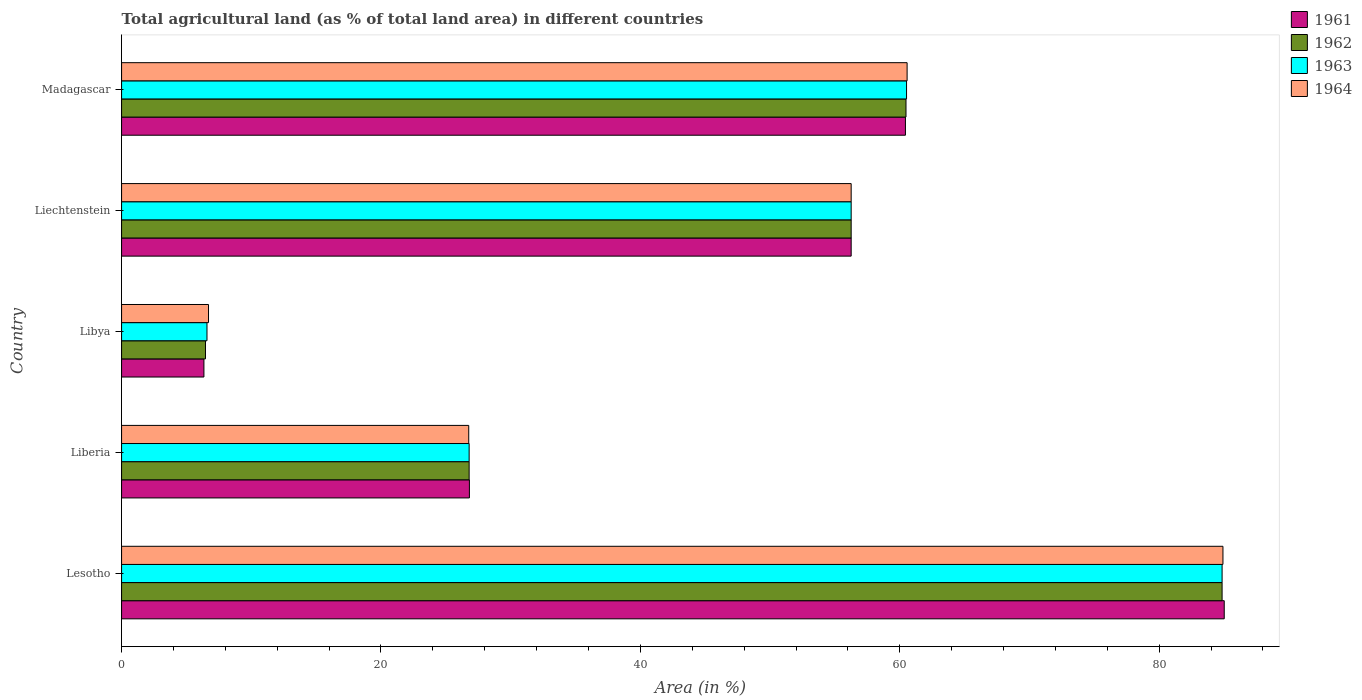Are the number of bars per tick equal to the number of legend labels?
Keep it short and to the point. Yes. How many bars are there on the 2nd tick from the top?
Your answer should be compact. 4. How many bars are there on the 3rd tick from the bottom?
Keep it short and to the point. 4. What is the label of the 4th group of bars from the top?
Make the answer very short. Liberia. What is the percentage of agricultural land in 1962 in Liberia?
Provide a short and direct response. 26.8. Across all countries, what is the maximum percentage of agricultural land in 1962?
Your answer should be very brief. 84.85. Across all countries, what is the minimum percentage of agricultural land in 1961?
Your answer should be compact. 6.35. In which country was the percentage of agricultural land in 1962 maximum?
Give a very brief answer. Lesotho. In which country was the percentage of agricultural land in 1961 minimum?
Ensure brevity in your answer.  Libya. What is the total percentage of agricultural land in 1964 in the graph?
Offer a terse response. 235.19. What is the difference between the percentage of agricultural land in 1962 in Lesotho and that in Madagascar?
Keep it short and to the point. 24.37. What is the difference between the percentage of agricultural land in 1962 in Liberia and the percentage of agricultural land in 1964 in Lesotho?
Offer a terse response. -58.12. What is the average percentage of agricultural land in 1963 per country?
Provide a succinct answer. 47. What is the difference between the percentage of agricultural land in 1963 and percentage of agricultural land in 1964 in Liberia?
Your answer should be compact. 0.03. What is the ratio of the percentage of agricultural land in 1962 in Liberia to that in Liechtenstein?
Give a very brief answer. 0.48. Is the difference between the percentage of agricultural land in 1963 in Libya and Liechtenstein greater than the difference between the percentage of agricultural land in 1964 in Libya and Liechtenstein?
Your response must be concise. No. What is the difference between the highest and the second highest percentage of agricultural land in 1962?
Your answer should be very brief. 24.37. What is the difference between the highest and the lowest percentage of agricultural land in 1962?
Your answer should be very brief. 78.38. In how many countries, is the percentage of agricultural land in 1963 greater than the average percentage of agricultural land in 1963 taken over all countries?
Provide a succinct answer. 3. Is it the case that in every country, the sum of the percentage of agricultural land in 1962 and percentage of agricultural land in 1964 is greater than the sum of percentage of agricultural land in 1961 and percentage of agricultural land in 1963?
Provide a succinct answer. No. What does the 3rd bar from the top in Liberia represents?
Offer a terse response. 1962. What does the 3rd bar from the bottom in Libya represents?
Give a very brief answer. 1963. How many bars are there?
Keep it short and to the point. 20. Are all the bars in the graph horizontal?
Your answer should be compact. Yes. How many countries are there in the graph?
Your response must be concise. 5. What is the difference between two consecutive major ticks on the X-axis?
Make the answer very short. 20. Are the values on the major ticks of X-axis written in scientific E-notation?
Offer a terse response. No. Does the graph contain any zero values?
Offer a terse response. No. How are the legend labels stacked?
Your answer should be compact. Vertical. What is the title of the graph?
Keep it short and to the point. Total agricultural land (as % of total land area) in different countries. Does "2004" appear as one of the legend labels in the graph?
Provide a short and direct response. No. What is the label or title of the X-axis?
Make the answer very short. Area (in %). What is the Area (in %) in 1961 in Lesotho?
Your answer should be very brief. 85.01. What is the Area (in %) of 1962 in Lesotho?
Your answer should be very brief. 84.85. What is the Area (in %) in 1963 in Lesotho?
Provide a succinct answer. 84.85. What is the Area (in %) in 1964 in Lesotho?
Keep it short and to the point. 84.91. What is the Area (in %) in 1961 in Liberia?
Your answer should be compact. 26.82. What is the Area (in %) in 1962 in Liberia?
Your answer should be very brief. 26.8. What is the Area (in %) in 1963 in Liberia?
Keep it short and to the point. 26.8. What is the Area (in %) of 1964 in Liberia?
Make the answer very short. 26.76. What is the Area (in %) of 1961 in Libya?
Give a very brief answer. 6.35. What is the Area (in %) in 1962 in Libya?
Your answer should be compact. 6.47. What is the Area (in %) of 1963 in Libya?
Give a very brief answer. 6.58. What is the Area (in %) in 1964 in Libya?
Your response must be concise. 6.7. What is the Area (in %) of 1961 in Liechtenstein?
Provide a short and direct response. 56.25. What is the Area (in %) in 1962 in Liechtenstein?
Provide a succinct answer. 56.25. What is the Area (in %) of 1963 in Liechtenstein?
Your response must be concise. 56.25. What is the Area (in %) in 1964 in Liechtenstein?
Offer a terse response. 56.25. What is the Area (in %) in 1961 in Madagascar?
Provide a succinct answer. 60.43. What is the Area (in %) of 1962 in Madagascar?
Provide a short and direct response. 60.48. What is the Area (in %) in 1963 in Madagascar?
Keep it short and to the point. 60.52. What is the Area (in %) in 1964 in Madagascar?
Keep it short and to the point. 60.56. Across all countries, what is the maximum Area (in %) of 1961?
Make the answer very short. 85.01. Across all countries, what is the maximum Area (in %) in 1962?
Your response must be concise. 84.85. Across all countries, what is the maximum Area (in %) in 1963?
Provide a short and direct response. 84.85. Across all countries, what is the maximum Area (in %) in 1964?
Keep it short and to the point. 84.91. Across all countries, what is the minimum Area (in %) in 1961?
Offer a very short reply. 6.35. Across all countries, what is the minimum Area (in %) of 1962?
Make the answer very short. 6.47. Across all countries, what is the minimum Area (in %) in 1963?
Offer a terse response. 6.58. Across all countries, what is the minimum Area (in %) in 1964?
Offer a very short reply. 6.7. What is the total Area (in %) of 1961 in the graph?
Offer a very short reply. 234.86. What is the total Area (in %) in 1962 in the graph?
Offer a terse response. 234.84. What is the total Area (in %) in 1963 in the graph?
Provide a succinct answer. 235. What is the total Area (in %) of 1964 in the graph?
Keep it short and to the point. 235.19. What is the difference between the Area (in %) of 1961 in Lesotho and that in Liberia?
Make the answer very short. 58.2. What is the difference between the Area (in %) in 1962 in Lesotho and that in Liberia?
Offer a terse response. 58.05. What is the difference between the Area (in %) of 1963 in Lesotho and that in Liberia?
Your answer should be very brief. 58.05. What is the difference between the Area (in %) in 1964 in Lesotho and that in Liberia?
Keep it short and to the point. 58.15. What is the difference between the Area (in %) in 1961 in Lesotho and that in Libya?
Offer a very short reply. 78.66. What is the difference between the Area (in %) in 1962 in Lesotho and that in Libya?
Offer a very short reply. 78.38. What is the difference between the Area (in %) in 1963 in Lesotho and that in Libya?
Offer a terse response. 78.26. What is the difference between the Area (in %) in 1964 in Lesotho and that in Libya?
Ensure brevity in your answer.  78.21. What is the difference between the Area (in %) in 1961 in Lesotho and that in Liechtenstein?
Your answer should be very brief. 28.76. What is the difference between the Area (in %) in 1962 in Lesotho and that in Liechtenstein?
Give a very brief answer. 28.6. What is the difference between the Area (in %) in 1963 in Lesotho and that in Liechtenstein?
Give a very brief answer. 28.6. What is the difference between the Area (in %) in 1964 in Lesotho and that in Liechtenstein?
Your answer should be compact. 28.66. What is the difference between the Area (in %) of 1961 in Lesotho and that in Madagascar?
Offer a terse response. 24.58. What is the difference between the Area (in %) of 1962 in Lesotho and that in Madagascar?
Make the answer very short. 24.37. What is the difference between the Area (in %) of 1963 in Lesotho and that in Madagascar?
Give a very brief answer. 24.33. What is the difference between the Area (in %) of 1964 in Lesotho and that in Madagascar?
Offer a terse response. 24.35. What is the difference between the Area (in %) of 1961 in Liberia and that in Libya?
Provide a short and direct response. 20.47. What is the difference between the Area (in %) of 1962 in Liberia and that in Libya?
Make the answer very short. 20.33. What is the difference between the Area (in %) in 1963 in Liberia and that in Libya?
Your answer should be very brief. 20.21. What is the difference between the Area (in %) of 1964 in Liberia and that in Libya?
Your response must be concise. 20.06. What is the difference between the Area (in %) in 1961 in Liberia and that in Liechtenstein?
Your answer should be compact. -29.43. What is the difference between the Area (in %) in 1962 in Liberia and that in Liechtenstein?
Your response must be concise. -29.45. What is the difference between the Area (in %) of 1963 in Liberia and that in Liechtenstein?
Make the answer very short. -29.45. What is the difference between the Area (in %) in 1964 in Liberia and that in Liechtenstein?
Offer a terse response. -29.48. What is the difference between the Area (in %) of 1961 in Liberia and that in Madagascar?
Make the answer very short. -33.62. What is the difference between the Area (in %) of 1962 in Liberia and that in Madagascar?
Make the answer very short. -33.68. What is the difference between the Area (in %) of 1963 in Liberia and that in Madagascar?
Offer a terse response. -33.72. What is the difference between the Area (in %) of 1964 in Liberia and that in Madagascar?
Your response must be concise. -33.8. What is the difference between the Area (in %) of 1961 in Libya and that in Liechtenstein?
Offer a very short reply. -49.9. What is the difference between the Area (in %) in 1962 in Libya and that in Liechtenstein?
Ensure brevity in your answer.  -49.78. What is the difference between the Area (in %) of 1963 in Libya and that in Liechtenstein?
Your response must be concise. -49.67. What is the difference between the Area (in %) in 1964 in Libya and that in Liechtenstein?
Make the answer very short. -49.55. What is the difference between the Area (in %) in 1961 in Libya and that in Madagascar?
Your response must be concise. -54.09. What is the difference between the Area (in %) in 1962 in Libya and that in Madagascar?
Your response must be concise. -54.01. What is the difference between the Area (in %) in 1963 in Libya and that in Madagascar?
Provide a short and direct response. -53.94. What is the difference between the Area (in %) of 1964 in Libya and that in Madagascar?
Your answer should be very brief. -53.86. What is the difference between the Area (in %) in 1961 in Liechtenstein and that in Madagascar?
Provide a short and direct response. -4.18. What is the difference between the Area (in %) of 1962 in Liechtenstein and that in Madagascar?
Offer a very short reply. -4.23. What is the difference between the Area (in %) in 1963 in Liechtenstein and that in Madagascar?
Provide a succinct answer. -4.27. What is the difference between the Area (in %) in 1964 in Liechtenstein and that in Madagascar?
Give a very brief answer. -4.31. What is the difference between the Area (in %) of 1961 in Lesotho and the Area (in %) of 1962 in Liberia?
Your response must be concise. 58.22. What is the difference between the Area (in %) of 1961 in Lesotho and the Area (in %) of 1963 in Liberia?
Your answer should be very brief. 58.22. What is the difference between the Area (in %) of 1961 in Lesotho and the Area (in %) of 1964 in Liberia?
Offer a very short reply. 58.25. What is the difference between the Area (in %) of 1962 in Lesotho and the Area (in %) of 1963 in Liberia?
Keep it short and to the point. 58.05. What is the difference between the Area (in %) of 1962 in Lesotho and the Area (in %) of 1964 in Liberia?
Your response must be concise. 58.08. What is the difference between the Area (in %) in 1963 in Lesotho and the Area (in %) in 1964 in Liberia?
Your answer should be very brief. 58.08. What is the difference between the Area (in %) in 1961 in Lesotho and the Area (in %) in 1962 in Libya?
Ensure brevity in your answer.  78.54. What is the difference between the Area (in %) in 1961 in Lesotho and the Area (in %) in 1963 in Libya?
Ensure brevity in your answer.  78.43. What is the difference between the Area (in %) of 1961 in Lesotho and the Area (in %) of 1964 in Libya?
Provide a succinct answer. 78.31. What is the difference between the Area (in %) in 1962 in Lesotho and the Area (in %) in 1963 in Libya?
Give a very brief answer. 78.26. What is the difference between the Area (in %) in 1962 in Lesotho and the Area (in %) in 1964 in Libya?
Give a very brief answer. 78.15. What is the difference between the Area (in %) in 1963 in Lesotho and the Area (in %) in 1964 in Libya?
Give a very brief answer. 78.15. What is the difference between the Area (in %) of 1961 in Lesotho and the Area (in %) of 1962 in Liechtenstein?
Offer a terse response. 28.76. What is the difference between the Area (in %) in 1961 in Lesotho and the Area (in %) in 1963 in Liechtenstein?
Your answer should be compact. 28.76. What is the difference between the Area (in %) of 1961 in Lesotho and the Area (in %) of 1964 in Liechtenstein?
Ensure brevity in your answer.  28.76. What is the difference between the Area (in %) of 1962 in Lesotho and the Area (in %) of 1963 in Liechtenstein?
Provide a short and direct response. 28.6. What is the difference between the Area (in %) of 1962 in Lesotho and the Area (in %) of 1964 in Liechtenstein?
Keep it short and to the point. 28.6. What is the difference between the Area (in %) of 1963 in Lesotho and the Area (in %) of 1964 in Liechtenstein?
Your answer should be compact. 28.6. What is the difference between the Area (in %) in 1961 in Lesotho and the Area (in %) in 1962 in Madagascar?
Offer a very short reply. 24.54. What is the difference between the Area (in %) in 1961 in Lesotho and the Area (in %) in 1963 in Madagascar?
Your answer should be compact. 24.49. What is the difference between the Area (in %) of 1961 in Lesotho and the Area (in %) of 1964 in Madagascar?
Give a very brief answer. 24.45. What is the difference between the Area (in %) in 1962 in Lesotho and the Area (in %) in 1963 in Madagascar?
Make the answer very short. 24.33. What is the difference between the Area (in %) of 1962 in Lesotho and the Area (in %) of 1964 in Madagascar?
Provide a short and direct response. 24.29. What is the difference between the Area (in %) in 1963 in Lesotho and the Area (in %) in 1964 in Madagascar?
Make the answer very short. 24.29. What is the difference between the Area (in %) in 1961 in Liberia and the Area (in %) in 1962 in Libya?
Provide a short and direct response. 20.35. What is the difference between the Area (in %) in 1961 in Liberia and the Area (in %) in 1963 in Libya?
Your answer should be compact. 20.23. What is the difference between the Area (in %) of 1961 in Liberia and the Area (in %) of 1964 in Libya?
Your response must be concise. 20.11. What is the difference between the Area (in %) of 1962 in Liberia and the Area (in %) of 1963 in Libya?
Provide a short and direct response. 20.21. What is the difference between the Area (in %) of 1962 in Liberia and the Area (in %) of 1964 in Libya?
Your answer should be compact. 20.09. What is the difference between the Area (in %) in 1963 in Liberia and the Area (in %) in 1964 in Libya?
Provide a succinct answer. 20.09. What is the difference between the Area (in %) of 1961 in Liberia and the Area (in %) of 1962 in Liechtenstein?
Provide a short and direct response. -29.43. What is the difference between the Area (in %) of 1961 in Liberia and the Area (in %) of 1963 in Liechtenstein?
Give a very brief answer. -29.43. What is the difference between the Area (in %) of 1961 in Liberia and the Area (in %) of 1964 in Liechtenstein?
Ensure brevity in your answer.  -29.43. What is the difference between the Area (in %) in 1962 in Liberia and the Area (in %) in 1963 in Liechtenstein?
Offer a terse response. -29.45. What is the difference between the Area (in %) in 1962 in Liberia and the Area (in %) in 1964 in Liechtenstein?
Your answer should be compact. -29.45. What is the difference between the Area (in %) in 1963 in Liberia and the Area (in %) in 1964 in Liechtenstein?
Offer a very short reply. -29.45. What is the difference between the Area (in %) of 1961 in Liberia and the Area (in %) of 1962 in Madagascar?
Offer a terse response. -33.66. What is the difference between the Area (in %) in 1961 in Liberia and the Area (in %) in 1963 in Madagascar?
Your response must be concise. -33.7. What is the difference between the Area (in %) of 1961 in Liberia and the Area (in %) of 1964 in Madagascar?
Keep it short and to the point. -33.75. What is the difference between the Area (in %) in 1962 in Liberia and the Area (in %) in 1963 in Madagascar?
Keep it short and to the point. -33.72. What is the difference between the Area (in %) of 1962 in Liberia and the Area (in %) of 1964 in Madagascar?
Give a very brief answer. -33.77. What is the difference between the Area (in %) in 1963 in Liberia and the Area (in %) in 1964 in Madagascar?
Your answer should be compact. -33.77. What is the difference between the Area (in %) in 1961 in Libya and the Area (in %) in 1962 in Liechtenstein?
Provide a short and direct response. -49.9. What is the difference between the Area (in %) of 1961 in Libya and the Area (in %) of 1963 in Liechtenstein?
Make the answer very short. -49.9. What is the difference between the Area (in %) of 1961 in Libya and the Area (in %) of 1964 in Liechtenstein?
Offer a terse response. -49.9. What is the difference between the Area (in %) in 1962 in Libya and the Area (in %) in 1963 in Liechtenstein?
Keep it short and to the point. -49.78. What is the difference between the Area (in %) in 1962 in Libya and the Area (in %) in 1964 in Liechtenstein?
Ensure brevity in your answer.  -49.78. What is the difference between the Area (in %) in 1963 in Libya and the Area (in %) in 1964 in Liechtenstein?
Your response must be concise. -49.67. What is the difference between the Area (in %) in 1961 in Libya and the Area (in %) in 1962 in Madagascar?
Keep it short and to the point. -54.13. What is the difference between the Area (in %) of 1961 in Libya and the Area (in %) of 1963 in Madagascar?
Your response must be concise. -54.17. What is the difference between the Area (in %) of 1961 in Libya and the Area (in %) of 1964 in Madagascar?
Make the answer very short. -54.22. What is the difference between the Area (in %) of 1962 in Libya and the Area (in %) of 1963 in Madagascar?
Provide a short and direct response. -54.05. What is the difference between the Area (in %) of 1962 in Libya and the Area (in %) of 1964 in Madagascar?
Keep it short and to the point. -54.09. What is the difference between the Area (in %) of 1963 in Libya and the Area (in %) of 1964 in Madagascar?
Your answer should be very brief. -53.98. What is the difference between the Area (in %) in 1961 in Liechtenstein and the Area (in %) in 1962 in Madagascar?
Provide a succinct answer. -4.23. What is the difference between the Area (in %) of 1961 in Liechtenstein and the Area (in %) of 1963 in Madagascar?
Offer a very short reply. -4.27. What is the difference between the Area (in %) in 1961 in Liechtenstein and the Area (in %) in 1964 in Madagascar?
Offer a terse response. -4.31. What is the difference between the Area (in %) in 1962 in Liechtenstein and the Area (in %) in 1963 in Madagascar?
Your answer should be compact. -4.27. What is the difference between the Area (in %) of 1962 in Liechtenstein and the Area (in %) of 1964 in Madagascar?
Give a very brief answer. -4.31. What is the difference between the Area (in %) in 1963 in Liechtenstein and the Area (in %) in 1964 in Madagascar?
Your answer should be compact. -4.31. What is the average Area (in %) of 1961 per country?
Make the answer very short. 46.97. What is the average Area (in %) in 1962 per country?
Provide a succinct answer. 46.97. What is the average Area (in %) of 1963 per country?
Provide a succinct answer. 47. What is the average Area (in %) in 1964 per country?
Provide a short and direct response. 47.04. What is the difference between the Area (in %) in 1961 and Area (in %) in 1962 in Lesotho?
Offer a very short reply. 0.16. What is the difference between the Area (in %) of 1961 and Area (in %) of 1963 in Lesotho?
Make the answer very short. 0.16. What is the difference between the Area (in %) of 1961 and Area (in %) of 1964 in Lesotho?
Keep it short and to the point. 0.1. What is the difference between the Area (in %) in 1962 and Area (in %) in 1964 in Lesotho?
Make the answer very short. -0.07. What is the difference between the Area (in %) of 1963 and Area (in %) of 1964 in Lesotho?
Give a very brief answer. -0.07. What is the difference between the Area (in %) in 1961 and Area (in %) in 1962 in Liberia?
Give a very brief answer. 0.02. What is the difference between the Area (in %) of 1961 and Area (in %) of 1963 in Liberia?
Provide a short and direct response. 0.02. What is the difference between the Area (in %) of 1961 and Area (in %) of 1964 in Liberia?
Give a very brief answer. 0.05. What is the difference between the Area (in %) of 1962 and Area (in %) of 1964 in Liberia?
Your answer should be compact. 0.03. What is the difference between the Area (in %) of 1963 and Area (in %) of 1964 in Liberia?
Your answer should be very brief. 0.03. What is the difference between the Area (in %) of 1961 and Area (in %) of 1962 in Libya?
Your response must be concise. -0.12. What is the difference between the Area (in %) of 1961 and Area (in %) of 1963 in Libya?
Make the answer very short. -0.24. What is the difference between the Area (in %) of 1961 and Area (in %) of 1964 in Libya?
Make the answer very short. -0.35. What is the difference between the Area (in %) of 1962 and Area (in %) of 1963 in Libya?
Your response must be concise. -0.11. What is the difference between the Area (in %) of 1962 and Area (in %) of 1964 in Libya?
Offer a terse response. -0.23. What is the difference between the Area (in %) of 1963 and Area (in %) of 1964 in Libya?
Keep it short and to the point. -0.12. What is the difference between the Area (in %) in 1961 and Area (in %) in 1963 in Liechtenstein?
Offer a terse response. 0. What is the difference between the Area (in %) in 1961 and Area (in %) in 1964 in Liechtenstein?
Offer a very short reply. 0. What is the difference between the Area (in %) in 1962 and Area (in %) in 1963 in Liechtenstein?
Give a very brief answer. 0. What is the difference between the Area (in %) in 1962 and Area (in %) in 1964 in Liechtenstein?
Offer a terse response. 0. What is the difference between the Area (in %) in 1961 and Area (in %) in 1962 in Madagascar?
Offer a very short reply. -0.04. What is the difference between the Area (in %) of 1961 and Area (in %) of 1963 in Madagascar?
Make the answer very short. -0.09. What is the difference between the Area (in %) in 1961 and Area (in %) in 1964 in Madagascar?
Provide a succinct answer. -0.13. What is the difference between the Area (in %) of 1962 and Area (in %) of 1963 in Madagascar?
Ensure brevity in your answer.  -0.04. What is the difference between the Area (in %) of 1962 and Area (in %) of 1964 in Madagascar?
Keep it short and to the point. -0.09. What is the difference between the Area (in %) of 1963 and Area (in %) of 1964 in Madagascar?
Make the answer very short. -0.04. What is the ratio of the Area (in %) in 1961 in Lesotho to that in Liberia?
Make the answer very short. 3.17. What is the ratio of the Area (in %) in 1962 in Lesotho to that in Liberia?
Your answer should be compact. 3.17. What is the ratio of the Area (in %) in 1963 in Lesotho to that in Liberia?
Offer a very short reply. 3.17. What is the ratio of the Area (in %) in 1964 in Lesotho to that in Liberia?
Make the answer very short. 3.17. What is the ratio of the Area (in %) in 1961 in Lesotho to that in Libya?
Your answer should be compact. 13.39. What is the ratio of the Area (in %) of 1962 in Lesotho to that in Libya?
Keep it short and to the point. 13.12. What is the ratio of the Area (in %) of 1963 in Lesotho to that in Libya?
Make the answer very short. 12.89. What is the ratio of the Area (in %) of 1964 in Lesotho to that in Libya?
Keep it short and to the point. 12.67. What is the ratio of the Area (in %) in 1961 in Lesotho to that in Liechtenstein?
Give a very brief answer. 1.51. What is the ratio of the Area (in %) of 1962 in Lesotho to that in Liechtenstein?
Your answer should be compact. 1.51. What is the ratio of the Area (in %) of 1963 in Lesotho to that in Liechtenstein?
Give a very brief answer. 1.51. What is the ratio of the Area (in %) of 1964 in Lesotho to that in Liechtenstein?
Your answer should be very brief. 1.51. What is the ratio of the Area (in %) of 1961 in Lesotho to that in Madagascar?
Your answer should be compact. 1.41. What is the ratio of the Area (in %) in 1962 in Lesotho to that in Madagascar?
Keep it short and to the point. 1.4. What is the ratio of the Area (in %) in 1963 in Lesotho to that in Madagascar?
Ensure brevity in your answer.  1.4. What is the ratio of the Area (in %) in 1964 in Lesotho to that in Madagascar?
Make the answer very short. 1.4. What is the ratio of the Area (in %) of 1961 in Liberia to that in Libya?
Offer a very short reply. 4.22. What is the ratio of the Area (in %) of 1962 in Liberia to that in Libya?
Your response must be concise. 4.14. What is the ratio of the Area (in %) of 1963 in Liberia to that in Libya?
Your answer should be compact. 4.07. What is the ratio of the Area (in %) in 1964 in Liberia to that in Libya?
Provide a succinct answer. 3.99. What is the ratio of the Area (in %) in 1961 in Liberia to that in Liechtenstein?
Your answer should be compact. 0.48. What is the ratio of the Area (in %) in 1962 in Liberia to that in Liechtenstein?
Your answer should be compact. 0.48. What is the ratio of the Area (in %) of 1963 in Liberia to that in Liechtenstein?
Provide a succinct answer. 0.48. What is the ratio of the Area (in %) of 1964 in Liberia to that in Liechtenstein?
Your answer should be very brief. 0.48. What is the ratio of the Area (in %) of 1961 in Liberia to that in Madagascar?
Offer a terse response. 0.44. What is the ratio of the Area (in %) of 1962 in Liberia to that in Madagascar?
Ensure brevity in your answer.  0.44. What is the ratio of the Area (in %) in 1963 in Liberia to that in Madagascar?
Give a very brief answer. 0.44. What is the ratio of the Area (in %) in 1964 in Liberia to that in Madagascar?
Provide a succinct answer. 0.44. What is the ratio of the Area (in %) of 1961 in Libya to that in Liechtenstein?
Make the answer very short. 0.11. What is the ratio of the Area (in %) of 1962 in Libya to that in Liechtenstein?
Offer a terse response. 0.12. What is the ratio of the Area (in %) in 1963 in Libya to that in Liechtenstein?
Your answer should be very brief. 0.12. What is the ratio of the Area (in %) of 1964 in Libya to that in Liechtenstein?
Offer a very short reply. 0.12. What is the ratio of the Area (in %) of 1961 in Libya to that in Madagascar?
Provide a short and direct response. 0.1. What is the ratio of the Area (in %) of 1962 in Libya to that in Madagascar?
Provide a short and direct response. 0.11. What is the ratio of the Area (in %) of 1963 in Libya to that in Madagascar?
Keep it short and to the point. 0.11. What is the ratio of the Area (in %) in 1964 in Libya to that in Madagascar?
Offer a very short reply. 0.11. What is the ratio of the Area (in %) of 1961 in Liechtenstein to that in Madagascar?
Your response must be concise. 0.93. What is the ratio of the Area (in %) of 1962 in Liechtenstein to that in Madagascar?
Your answer should be very brief. 0.93. What is the ratio of the Area (in %) in 1963 in Liechtenstein to that in Madagascar?
Ensure brevity in your answer.  0.93. What is the ratio of the Area (in %) in 1964 in Liechtenstein to that in Madagascar?
Offer a terse response. 0.93. What is the difference between the highest and the second highest Area (in %) of 1961?
Offer a terse response. 24.58. What is the difference between the highest and the second highest Area (in %) of 1962?
Keep it short and to the point. 24.37. What is the difference between the highest and the second highest Area (in %) in 1963?
Keep it short and to the point. 24.33. What is the difference between the highest and the second highest Area (in %) in 1964?
Provide a short and direct response. 24.35. What is the difference between the highest and the lowest Area (in %) in 1961?
Provide a succinct answer. 78.66. What is the difference between the highest and the lowest Area (in %) of 1962?
Your answer should be very brief. 78.38. What is the difference between the highest and the lowest Area (in %) of 1963?
Offer a very short reply. 78.26. What is the difference between the highest and the lowest Area (in %) in 1964?
Make the answer very short. 78.21. 